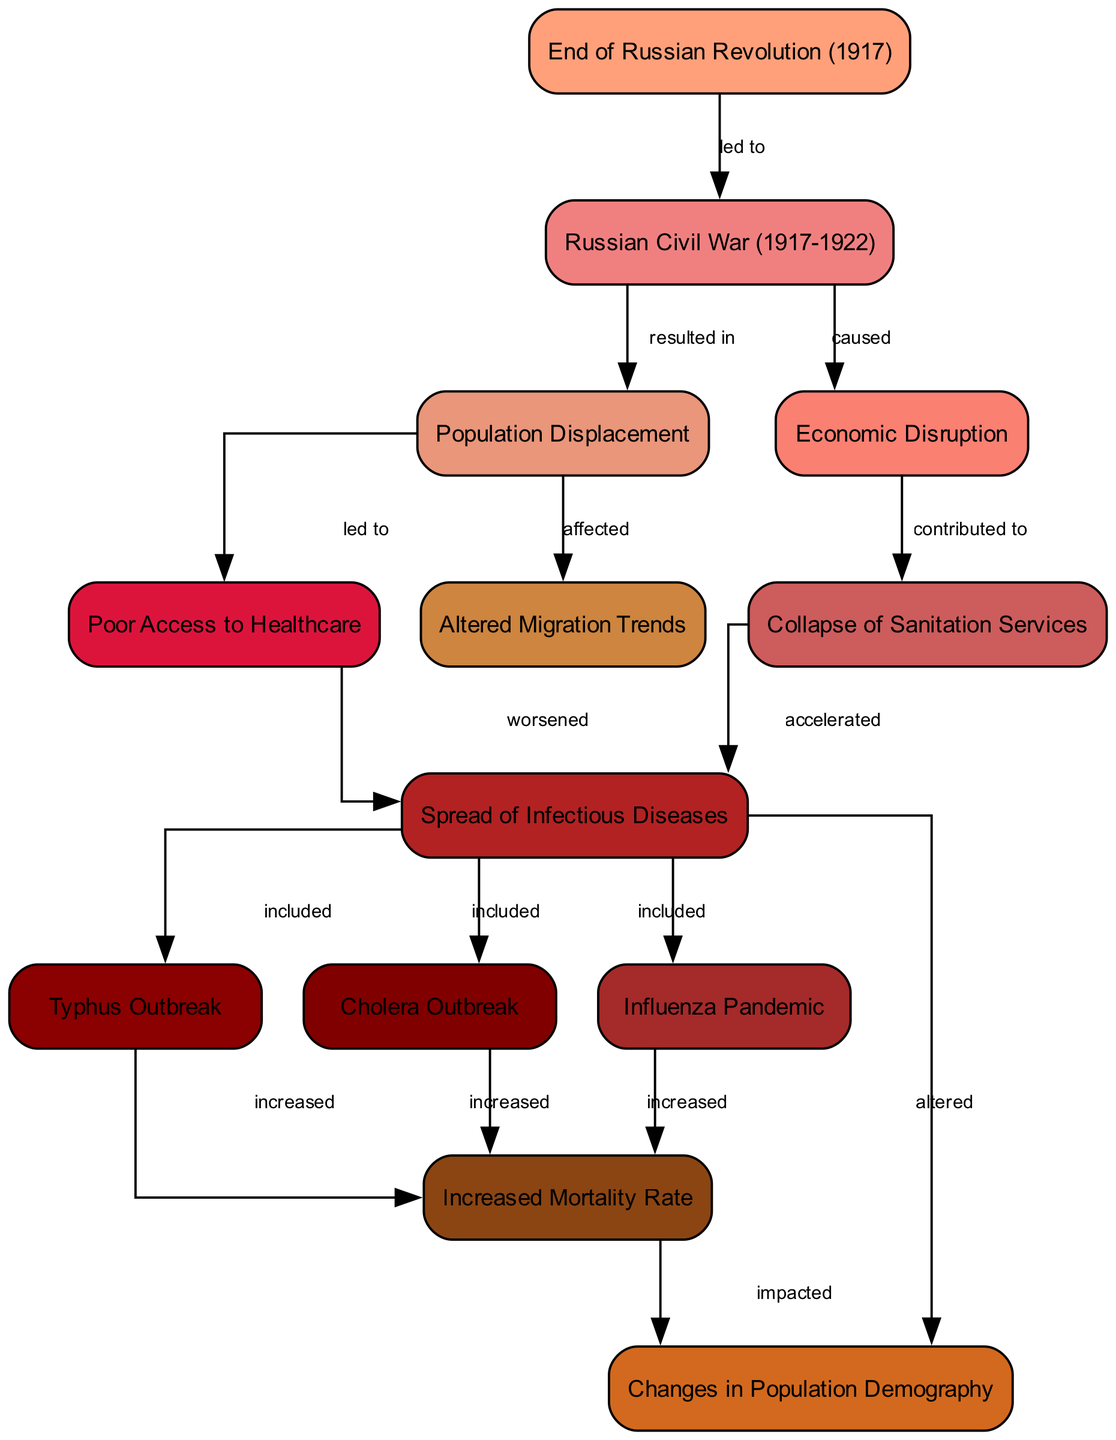What event led to the Russian Civil War? The diagram indicates that the "End of Russian Revolution (1917)" is directly connected to the "Russian Civil War (1917-1922)" through an edge labeled "led to", showing that the revolution's end initiated the civil conflict.
Answer: End of Russian Revolution (1917) What are the three infectious diseases included in the disease spread? The diagram connects the "Disease Spread" node to three specific disease nodes: "Typhus", "Cholera", and "Influenza", indicating that these diseases were part of the spread during that time.
Answer: Typhus, Cholera, Influenza How many nodes are there in the diagram? To find the total number of nodes, I counted each unique node listed. There are 13 distinct nodes present in the diagram, providing a complete view of the factors and outcomes related to infectious diseases in post-revolutionary Russia.
Answer: 13 What was one consequence of the collapse of sanitation services? The "Sanitation Collapse" node points to the "Disease Spread" node, indicating that the collapse of sanitation directly accelerated the spread of the diseases, which can be seen in the edge labeled "accelerated".
Answer: Disease Spread How did population displacement affect healthcare access? The diagram shows an edge from the "Population Displacement" node to the "Poor Access to Healthcare" node, labeled "led to", demonstrating that the displacement caused reductions in access to essential healthcare services.
Answer: Poor Access to Healthcare What impact did the increased mortality rate have on population demography? The "Mortality Rate" node connects to the "Population Demography" node with the label "impacted", meaning that the rise in mortality due to infectious diseases had significant effects on the demographic structure of the population.
Answer: impacted What contributed to the collapse of sanitation services? The "Economic Disruption" node has a connection labeled "contributed to" directed towards the "Sanitation Collapse", indicating that the economic turmoil during this period led to failures in sanitation provision.
Answer: Economic Disruption Which event resulted in population displacement? The diagram shows that the "Civil War" node is connected to the "Population Displacement" node via an edge labeled "resulted in," which indicates that the civil war was a major cause of people being displaced from their homes.
Answer: Russian Civil War (1917-1922) What alteration occurred in migration trends due to disease spread? The diagram indicates a direct link from "Population Displacement" to "Migration Trends" with the label "affected", suggesting that the disease spread, alongside population displacement, significantly changed migration patterns during this period.
Answer: Altered Migration Trends 